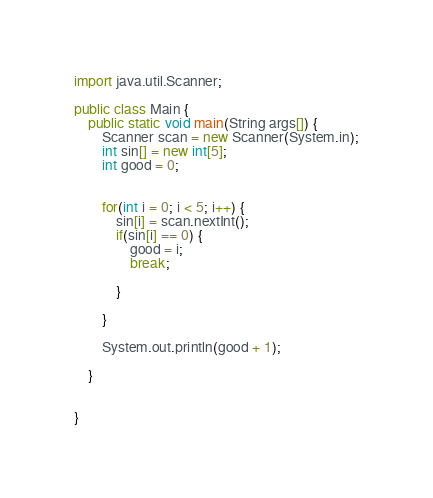<code> <loc_0><loc_0><loc_500><loc_500><_Java_>import java.util.Scanner;

public class Main {
	public static void main(String args[]) {
		Scanner scan = new Scanner(System.in);
		int sin[] = new int[5];
		int good = 0;
		
	
		for(int i = 0; i < 5; i++) {
			sin[i] = scan.nextInt();
			if(sin[i] == 0) {
				good = i;
				break;
				
			}
			
		}
		
		System.out.println(good + 1);
		
	}
		
	
}

</code> 